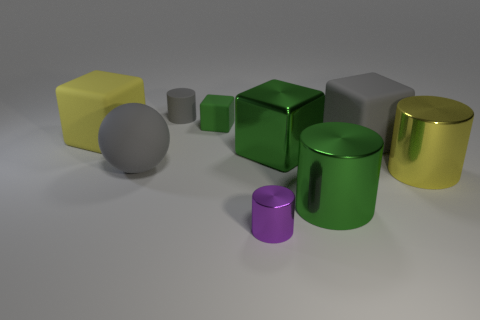Subtract all blue cubes. Subtract all gray cylinders. How many cubes are left? 4 Subtract all balls. How many objects are left? 8 Subtract all purple metallic objects. Subtract all tiny gray cylinders. How many objects are left? 7 Add 4 large yellow matte cubes. How many large yellow matte cubes are left? 5 Add 4 small red rubber things. How many small red rubber things exist? 4 Subtract 1 yellow cylinders. How many objects are left? 8 